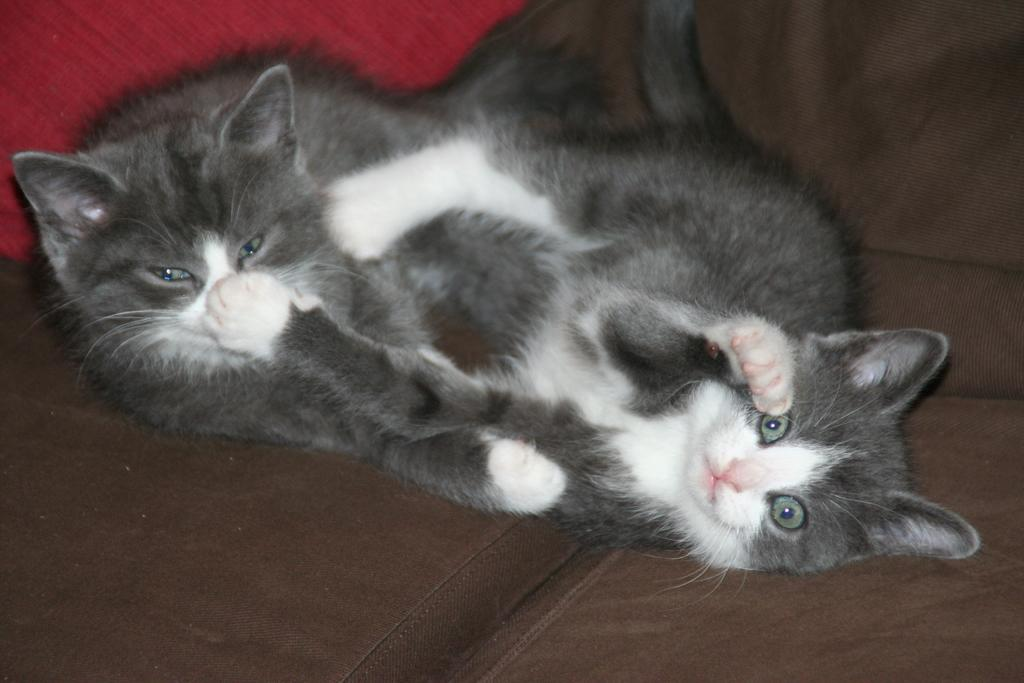How many cats are present in the image? There are two cats in the image. What are the cats doing in the image? The cats are laying on a sofa. What type of sock is the cat wearing on its paw in the image? There are no socks present in the image; the cats are not wearing any clothing. 